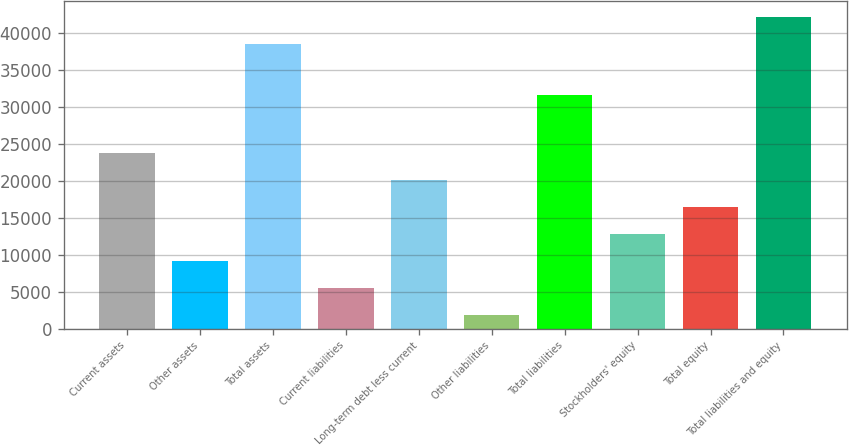Convert chart. <chart><loc_0><loc_0><loc_500><loc_500><bar_chart><fcel>Current assets<fcel>Other assets<fcel>Total assets<fcel>Current liabilities<fcel>Long-term debt less current<fcel>Other liabilities<fcel>Total liabilities<fcel>Stockholders' equity<fcel>Total equity<fcel>Total liabilities and equity<nl><fcel>23781.8<fcel>9116.6<fcel>38447<fcel>5450.3<fcel>20115.5<fcel>1784<fcel>31611<fcel>12782.9<fcel>16449.2<fcel>42113.3<nl></chart> 